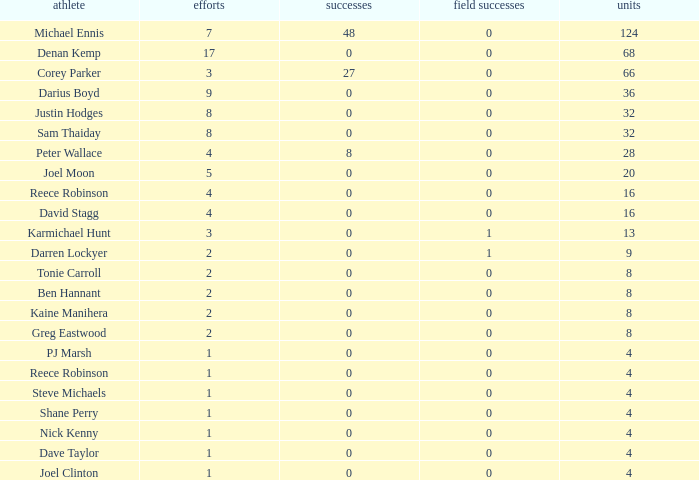How many goals did the player with less than 4 points have? 0.0. 